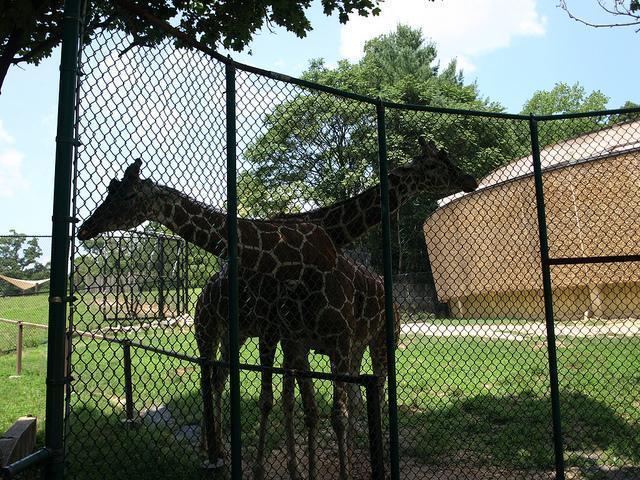How many animals are in the photo?
Give a very brief answer. 2. How many giraffes are in the photo?
Give a very brief answer. 2. 